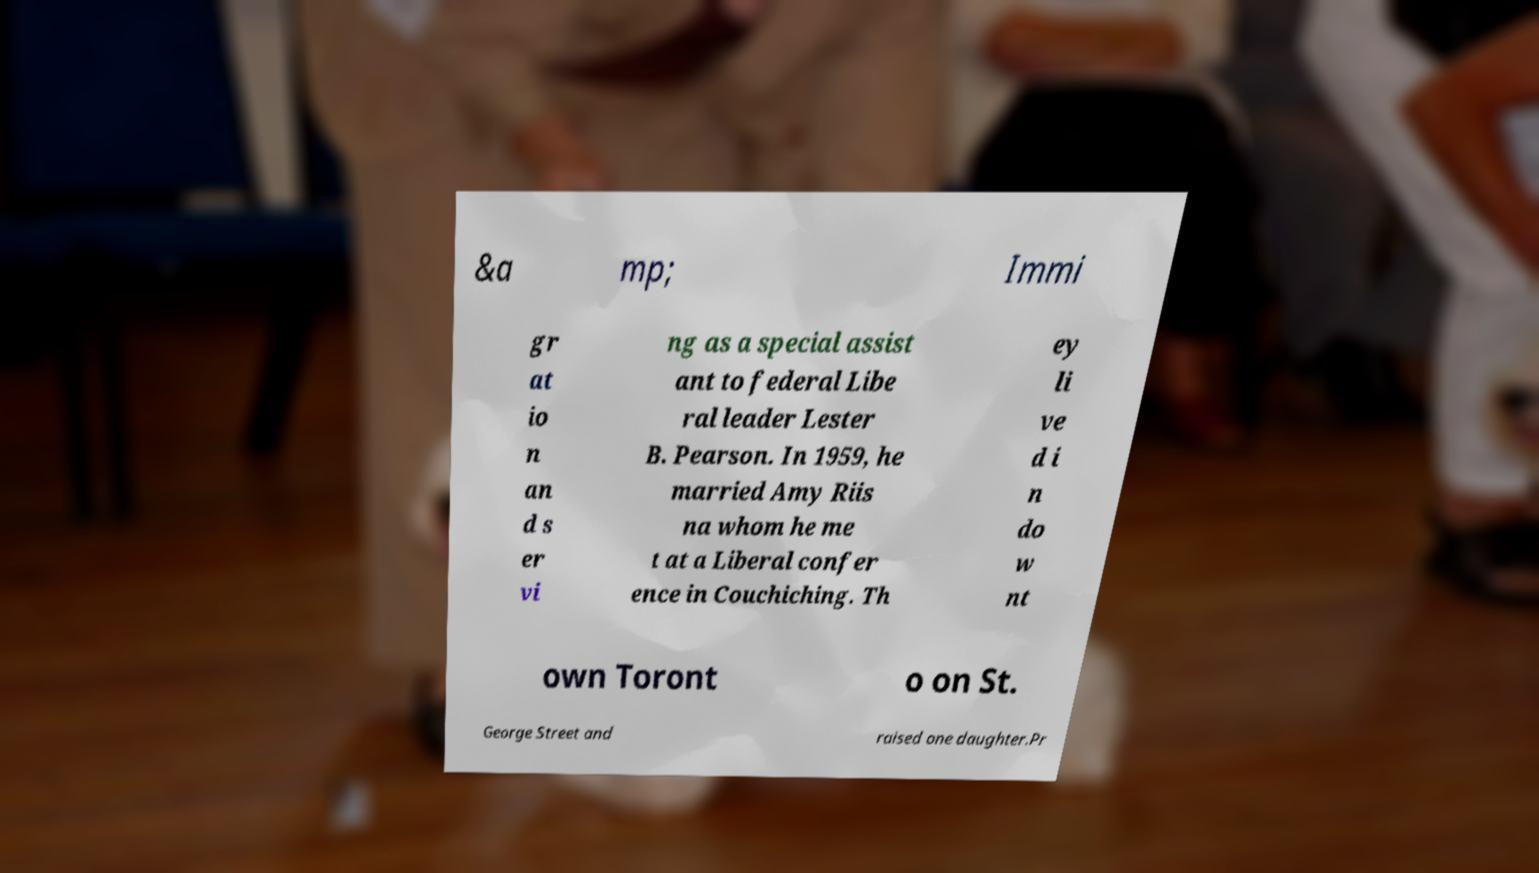Can you accurately transcribe the text from the provided image for me? &a mp; Immi gr at io n an d s er vi ng as a special assist ant to federal Libe ral leader Lester B. Pearson. In 1959, he married Amy Riis na whom he me t at a Liberal confer ence in Couchiching. Th ey li ve d i n do w nt own Toront o on St. George Street and raised one daughter.Pr 